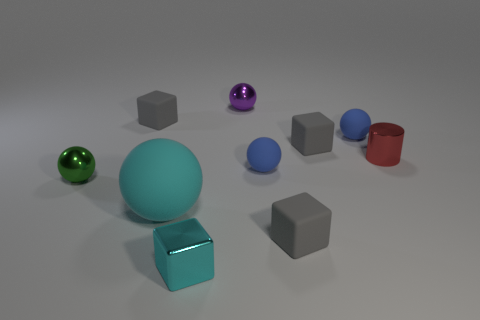How many objects are there altogether? In total, there are ten objects. They consist of six cubes, two spheres, and two cylindrical objects. Can you describe their arrangement? Certainly! The objects are arranged haphazardly on a flat surface. They are spread out, with no apparent pattern or grouping by shape or color. 